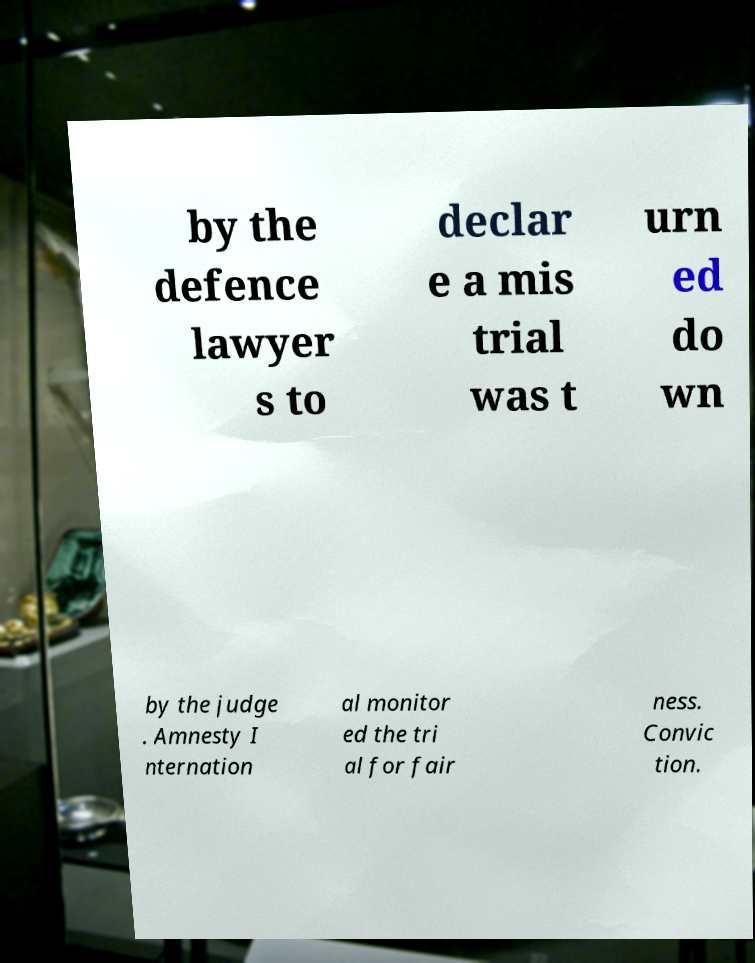Could you extract and type out the text from this image? by the defence lawyer s to declar e a mis trial was t urn ed do wn by the judge . Amnesty I nternation al monitor ed the tri al for fair ness. Convic tion. 